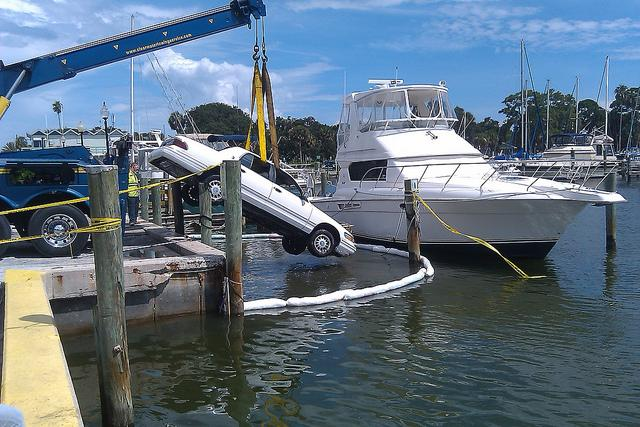Where has the white car on the yellow straps been? Please explain your reasoning. harbor water. The yellow harness is lifting the formerly submerged car. 